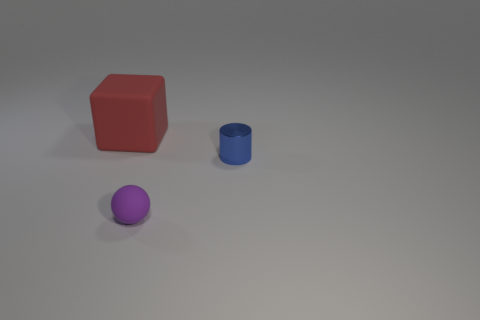Is there any other thing that has the same shape as the tiny metal object?
Make the answer very short. No. Is the thing that is left of the small purple sphere made of the same material as the blue object?
Give a very brief answer. No. Is the number of large red matte objects in front of the ball less than the number of big purple metal cubes?
Provide a succinct answer. No. What number of objects are either green matte balls or objects that are on the left side of the tiny rubber ball?
Provide a succinct answer. 1. There is a small sphere that is made of the same material as the large red cube; what color is it?
Provide a succinct answer. Purple. How many things are large red cubes or blue blocks?
Keep it short and to the point. 1. The thing that is the same size as the cylinder is what color?
Give a very brief answer. Purple. What number of things are either rubber objects to the left of the tiny rubber sphere or small red rubber balls?
Your response must be concise. 1. How many other objects are the same size as the blue object?
Offer a terse response. 1. There is a thing that is right of the small rubber ball; what size is it?
Ensure brevity in your answer.  Small. 